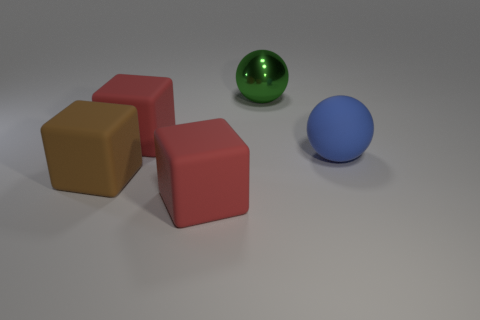Add 2 red metallic objects. How many objects exist? 7 Subtract all blocks. How many objects are left? 2 Subtract 0 gray cylinders. How many objects are left? 5 Subtract all small cyan matte objects. Subtract all large spheres. How many objects are left? 3 Add 2 red matte blocks. How many red matte blocks are left? 4 Add 5 large green rubber objects. How many large green rubber objects exist? 5 